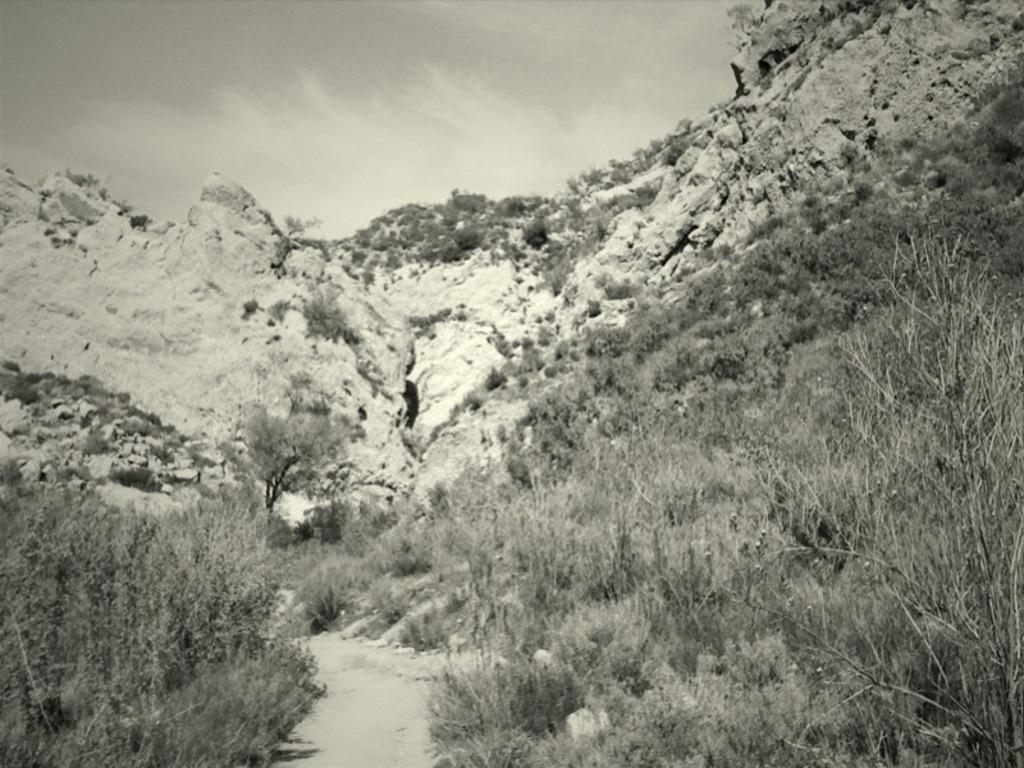What type of picture is in the image? The image contains a black and white picture. What natural elements can be seen in the image? There is a group of trees and a mountain in the image. What man-made feature is present in the image? There is a pathway in the image. How would you describe the sky in the image? The sky is cloudy in the image. Can you hear the girl whispering in the image? There is no girl present in the image, and therefore no whispering can be heard. 